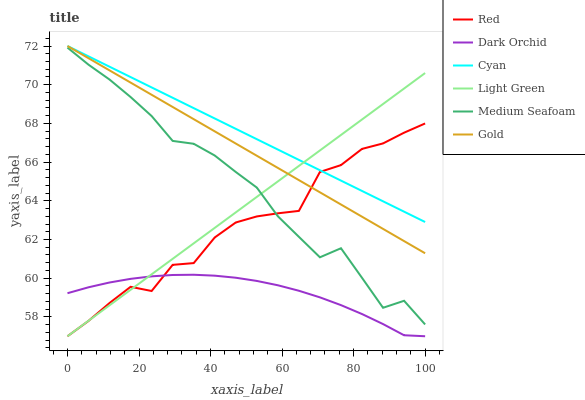Does Dark Orchid have the minimum area under the curve?
Answer yes or no. Yes. Does Cyan have the maximum area under the curve?
Answer yes or no. Yes. Does Light Green have the minimum area under the curve?
Answer yes or no. No. Does Light Green have the maximum area under the curve?
Answer yes or no. No. Is Cyan the smoothest?
Answer yes or no. Yes. Is Red the roughest?
Answer yes or no. Yes. Is Dark Orchid the smoothest?
Answer yes or no. No. Is Dark Orchid the roughest?
Answer yes or no. No. Does Cyan have the lowest value?
Answer yes or no. No. Does Cyan have the highest value?
Answer yes or no. Yes. Does Light Green have the highest value?
Answer yes or no. No. Is Medium Seafoam less than Gold?
Answer yes or no. Yes. Is Gold greater than Medium Seafoam?
Answer yes or no. Yes. Does Light Green intersect Medium Seafoam?
Answer yes or no. Yes. Is Light Green less than Medium Seafoam?
Answer yes or no. No. Is Light Green greater than Medium Seafoam?
Answer yes or no. No. Does Medium Seafoam intersect Gold?
Answer yes or no. No. 